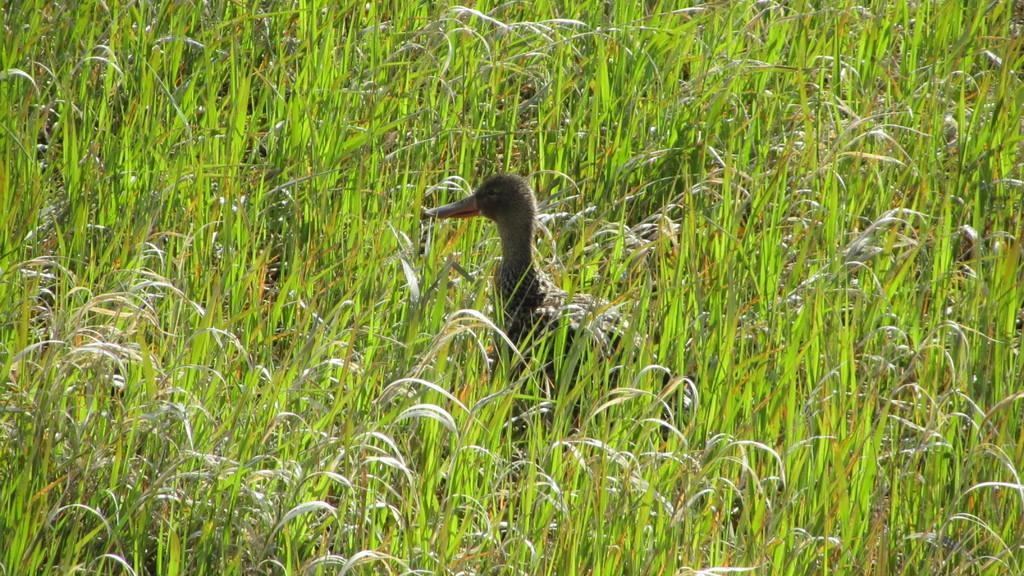Can you describe this image briefly? In this image there is a duck, around the duck there is grass. 